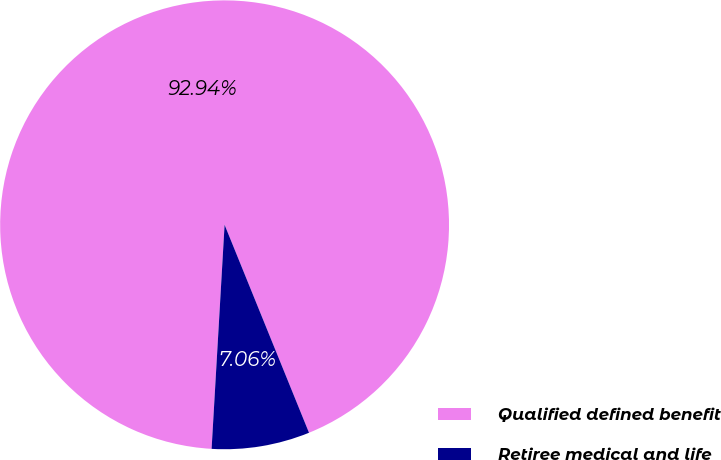Convert chart. <chart><loc_0><loc_0><loc_500><loc_500><pie_chart><fcel>Qualified defined benefit<fcel>Retiree medical and life<nl><fcel>92.94%<fcel>7.06%<nl></chart> 